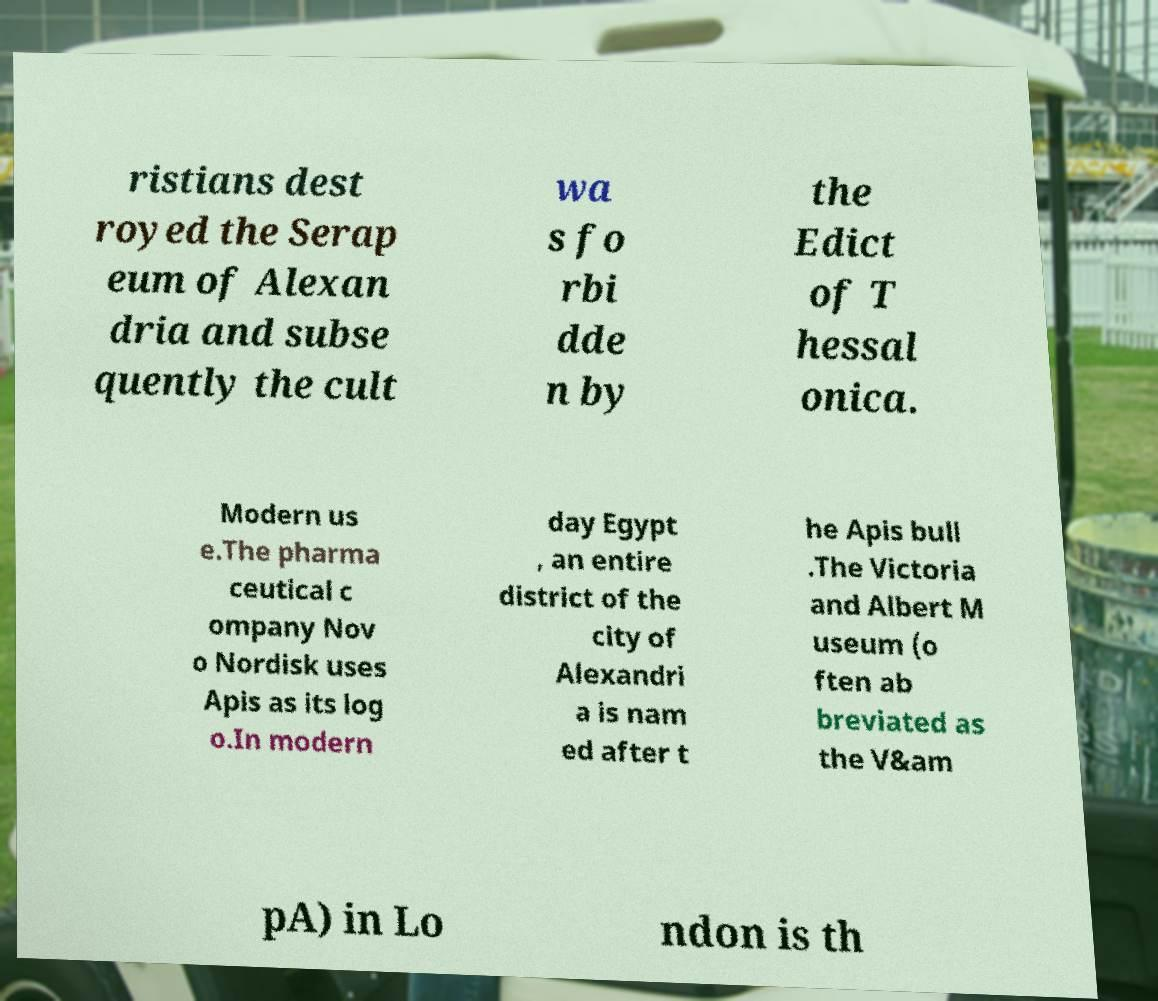Can you read and provide the text displayed in the image?This photo seems to have some interesting text. Can you extract and type it out for me? ristians dest royed the Serap eum of Alexan dria and subse quently the cult wa s fo rbi dde n by the Edict of T hessal onica. Modern us e.The pharma ceutical c ompany Nov o Nordisk uses Apis as its log o.In modern day Egypt , an entire district of the city of Alexandri a is nam ed after t he Apis bull .The Victoria and Albert M useum (o ften ab breviated as the V&am pA) in Lo ndon is th 